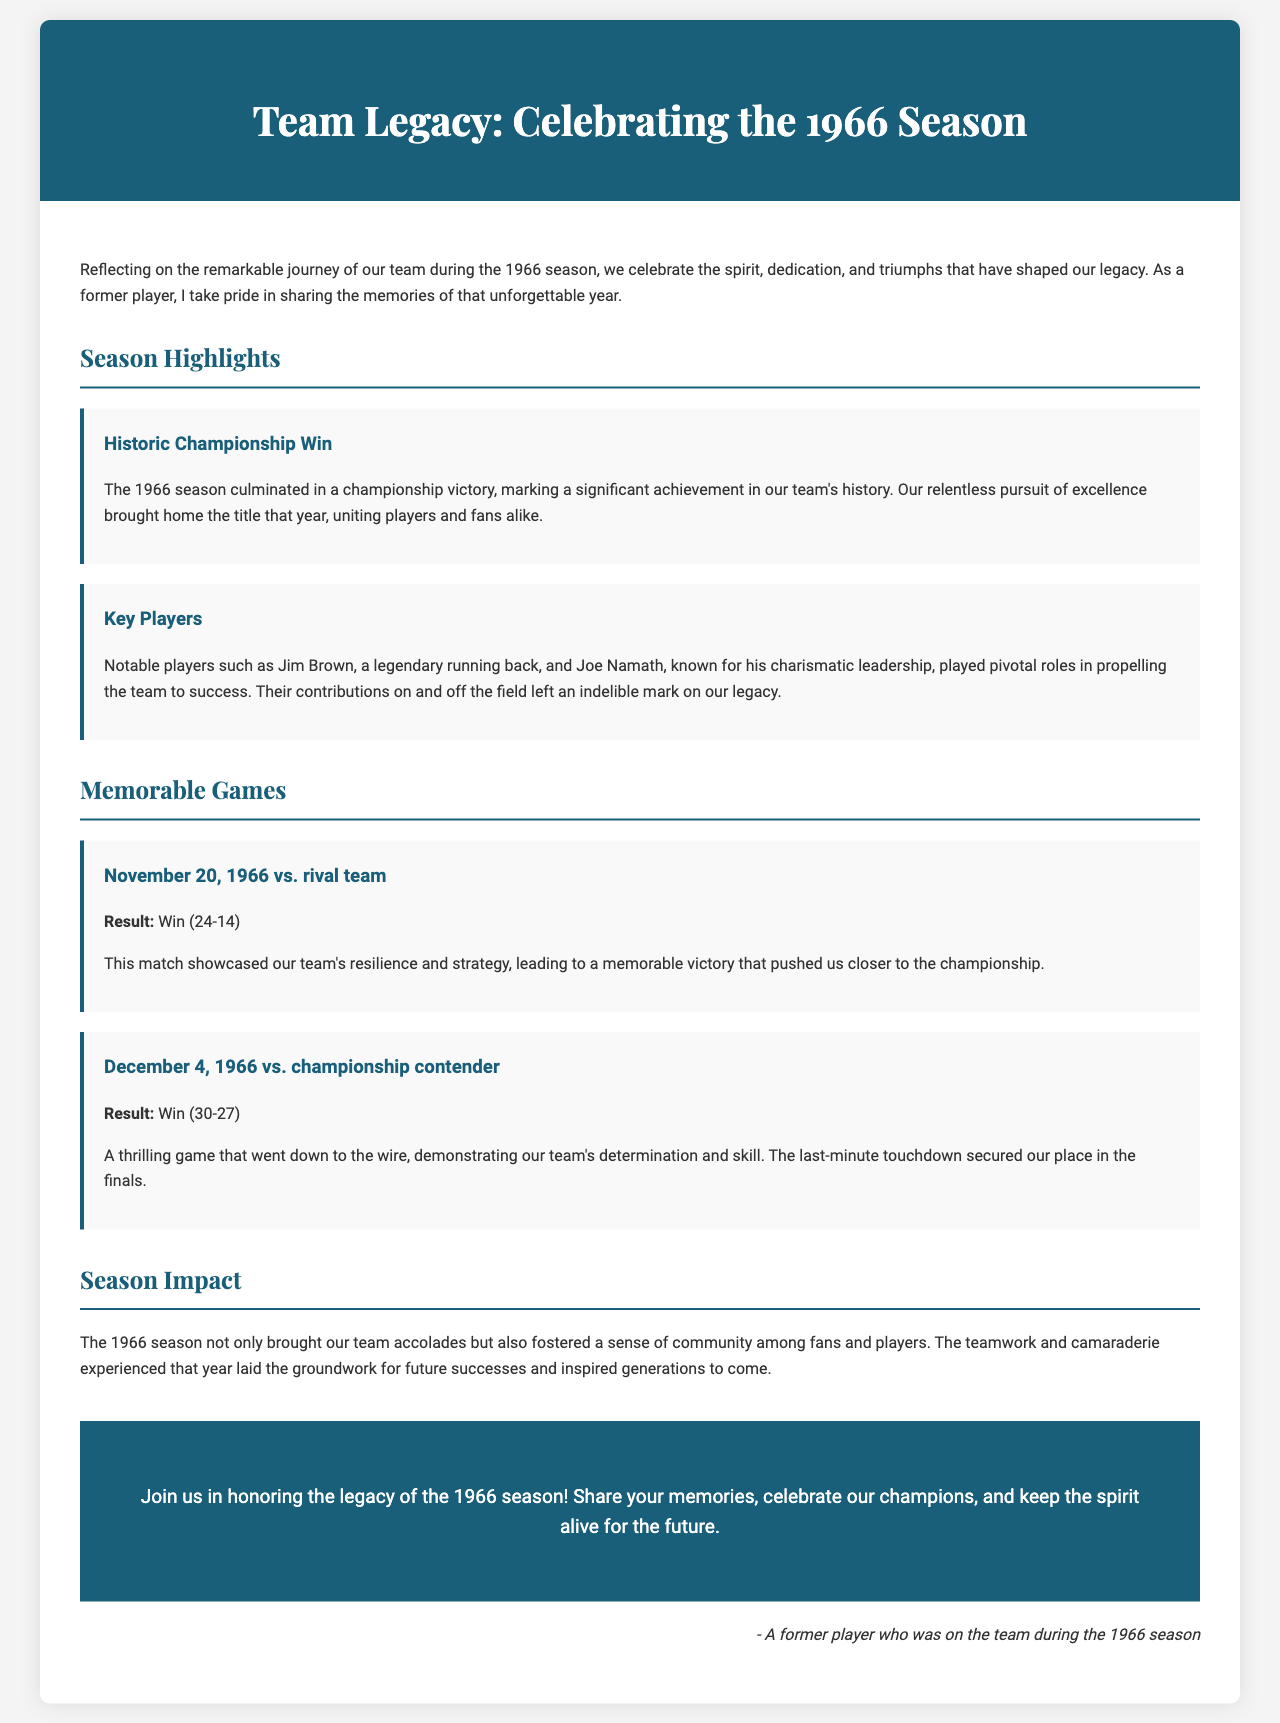what was the final result of the championship game? The final result of the championship game is summarized in the document, which states the championship victory occurred during the 1966 season.
Answer: Win who was a key player known for his charismatic leadership? The document mentions Joe Namath as a notable player and highlights his charismatic leadership.
Answer: Joe Namath which date featured a memorable game against a rival team? The specific date of the memorable game against a rival team is provided in the document as November 20, 1966.
Answer: November 20, 1966 what was the score of the game on December 4, 1966? The document presents the score of the game on December 4, 1966, which was a thrilling match that ended with a score of 30-27.
Answer: 30-27 what concept does the 1966 season symbolize in terms of team spirit? The document emphasizes that the 1966 season fostered a sense of community among fans and players, symbolizing a foundational teamwork.
Answer: Community how does the brochure invite readers to engage with the team’s legacy? The brochure encourages readers to join in honoring the legacy of the 1966 season through sharing memories and celebrating champions.
Answer: Share your memories what type of sporting achievement is highlighted in the document? The brochure highlights a historic championship win as a significant achievement in the team's history during the 1966 season.
Answer: Championship win which two players are specifically mentioned as key contributors to the team's success? The document names Jim Brown and Joe Namath as notable players who contributed to the team's success during the season.
Answer: Jim Brown, Joe Namath what color scheme is predominantly used in the header section of the brochure? The header section of the brochure uses a color scheme that includes a deep blue shade identified as #1a5f7a.
Answer: Deep blue 